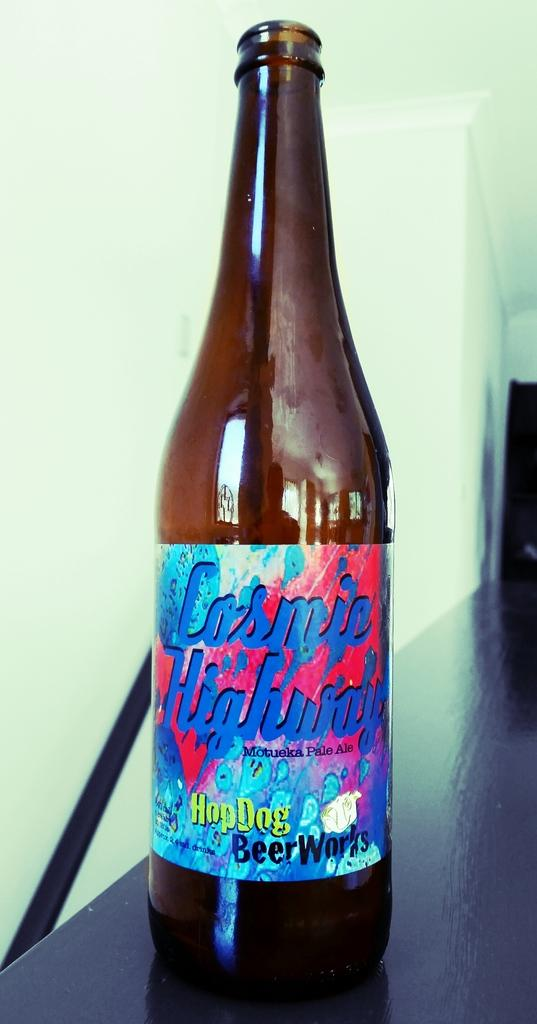What is the main object in the image? There is a bottle of beer in the image. Where is the bottle of beer located? The bottle of beer is placed on a table. What type of company is associated with the bottle of beer in the image? There is no indication of a company associated with the bottle of beer in the image. What does the mother of the person who owns the bottle of beer look like? There is no information about the person who owns the bottle of beer or their mother in the image. 